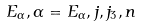Convert formula to latex. <formula><loc_0><loc_0><loc_500><loc_500>E _ { \alpha } , \alpha = E _ { \alpha } , j , j _ { 3 } , n</formula> 